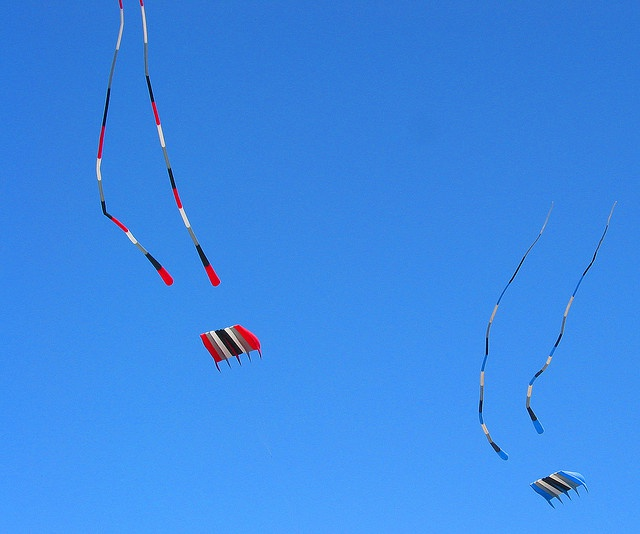Describe the objects in this image and their specific colors. I can see kite in blue, black, red, gray, and lightgray tones and kite in blue, black, and lightblue tones in this image. 